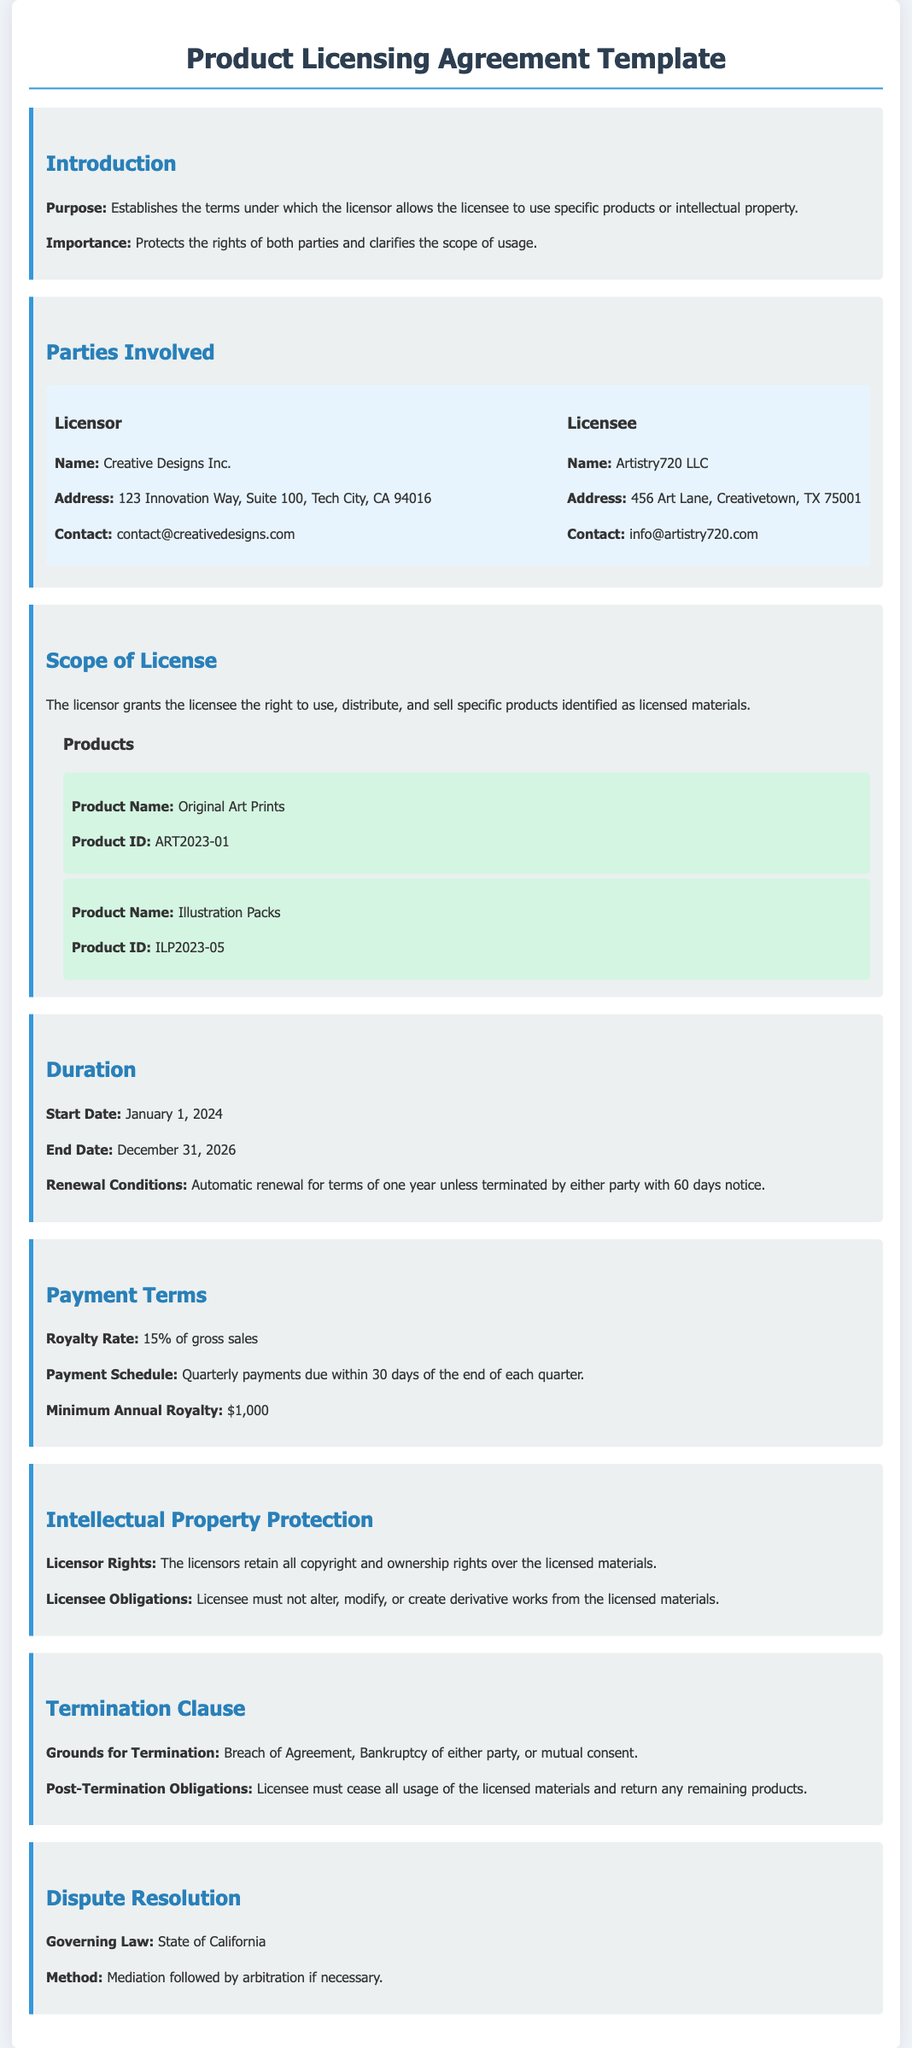What is the name of the Licensor? The Licensor's name is found in the "Parties Involved" section of the document.
Answer: Creative Designs Inc What is the address of the Licensee? The Licensee's address is indicated in the "Parties Involved" section.
Answer: 456 Art Lane, Creativetown, TX 75001 What is the royalty rate specified in the Payment Terms? The royalty rate is stated in the "Payment Terms" section.
Answer: 15% of gross sales When does the license agreement start? The start date is mentioned in the "Duration" section.
Answer: January 1, 2024 What is the minimum annual royalty? This amount is listed in the "Payment Terms" section.
Answer: $1,000 What are the grounds for termination of the agreement? The grounds are listed in the "Termination Clause" section.
Answer: Breach of Agreement, Bankruptcy of either party, or mutual consent What is the method of dispute resolution? The method is specified in the "Dispute Resolution" section.
Answer: Mediation followed by arbitration What is the end date of the license agreement? The end date is provided in the "Duration" section.
Answer: December 31, 2026 What obligations does the Licensee have regarding the licensed materials? The Licensee's obligations are specified in the "Intellectual Property Protection" section.
Answer: Licensee must not alter, modify, or create derivative works from the licensed materials 